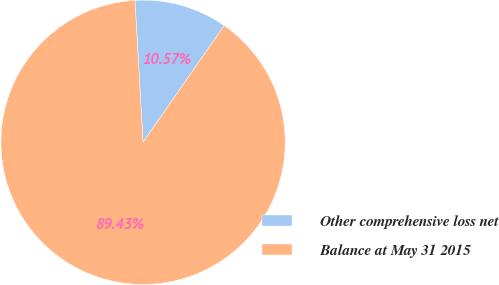Convert chart to OTSL. <chart><loc_0><loc_0><loc_500><loc_500><pie_chart><fcel>Other comprehensive loss net<fcel>Balance at May 31 2015<nl><fcel>10.57%<fcel>89.43%<nl></chart> 